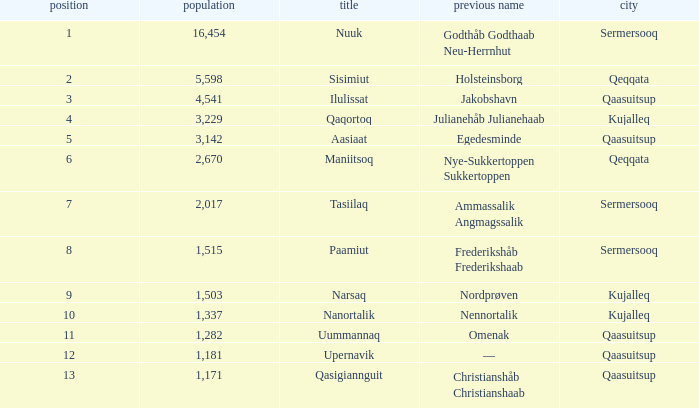What is the population for Rank 11? 1282.0. 